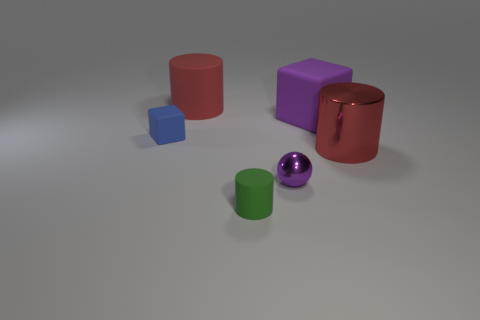There is a block that is the same size as the metal cylinder; what color is it?
Give a very brief answer. Purple. How many objects are big red cylinders that are on the left side of the large matte block or objects that are on the right side of the purple sphere?
Offer a terse response. 3. Are there an equal number of big rubber things that are in front of the tiny purple shiny thing and small green cylinders?
Your answer should be compact. No. Does the rubber cylinder that is in front of the blue object have the same size as the red cylinder that is left of the small green object?
Provide a succinct answer. No. What number of other things are the same size as the purple metal sphere?
Offer a very short reply. 2. There is a matte block to the right of the purple thing in front of the red metallic object; is there a big rubber cube that is behind it?
Keep it short and to the point. No. Is there any other thing that is the same color as the big matte block?
Make the answer very short. Yes. How big is the red cylinder behind the blue matte cube?
Provide a succinct answer. Large. There is a red thing that is left of the big cylinder in front of the cube to the right of the tiny cube; how big is it?
Make the answer very short. Large. There is a rubber cylinder that is behind the tiny metal object to the right of the green object; what color is it?
Make the answer very short. Red. 